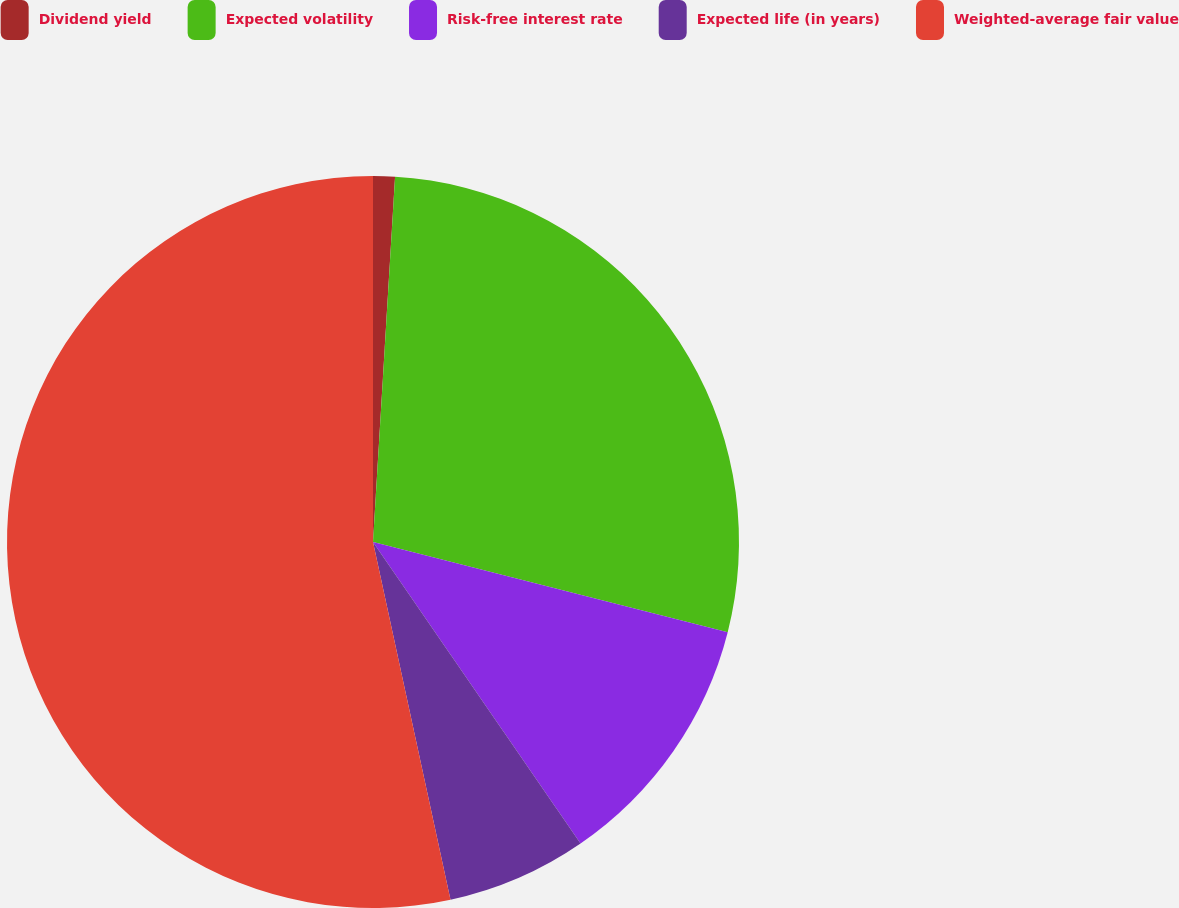Convert chart. <chart><loc_0><loc_0><loc_500><loc_500><pie_chart><fcel>Dividend yield<fcel>Expected volatility<fcel>Risk-free interest rate<fcel>Expected life (in years)<fcel>Weighted-average fair value<nl><fcel>0.96%<fcel>28.0%<fcel>11.44%<fcel>6.2%<fcel>53.39%<nl></chart> 